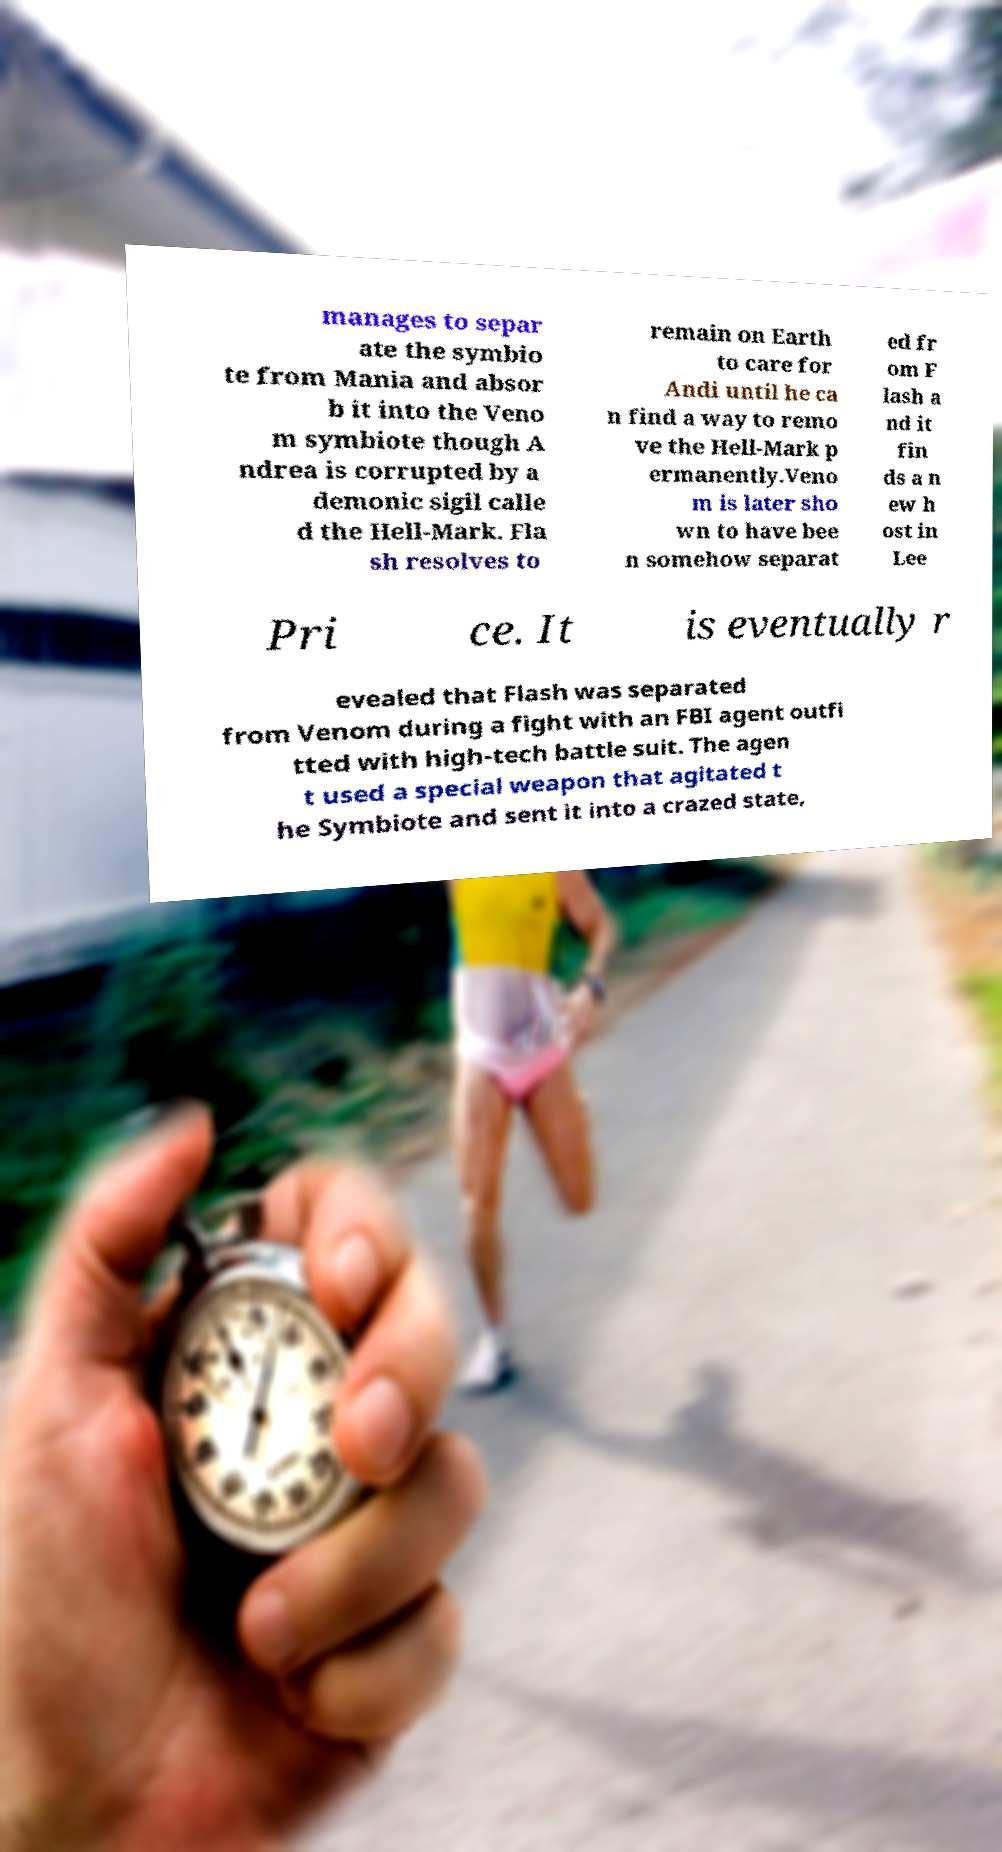There's text embedded in this image that I need extracted. Can you transcribe it verbatim? manages to separ ate the symbio te from Mania and absor b it into the Veno m symbiote though A ndrea is corrupted by a demonic sigil calle d the Hell-Mark. Fla sh resolves to remain on Earth to care for Andi until he ca n find a way to remo ve the Hell-Mark p ermanently.Veno m is later sho wn to have bee n somehow separat ed fr om F lash a nd it fin ds a n ew h ost in Lee Pri ce. It is eventually r evealed that Flash was separated from Venom during a fight with an FBI agent outfi tted with high-tech battle suit. The agen t used a special weapon that agitated t he Symbiote and sent it into a crazed state, 